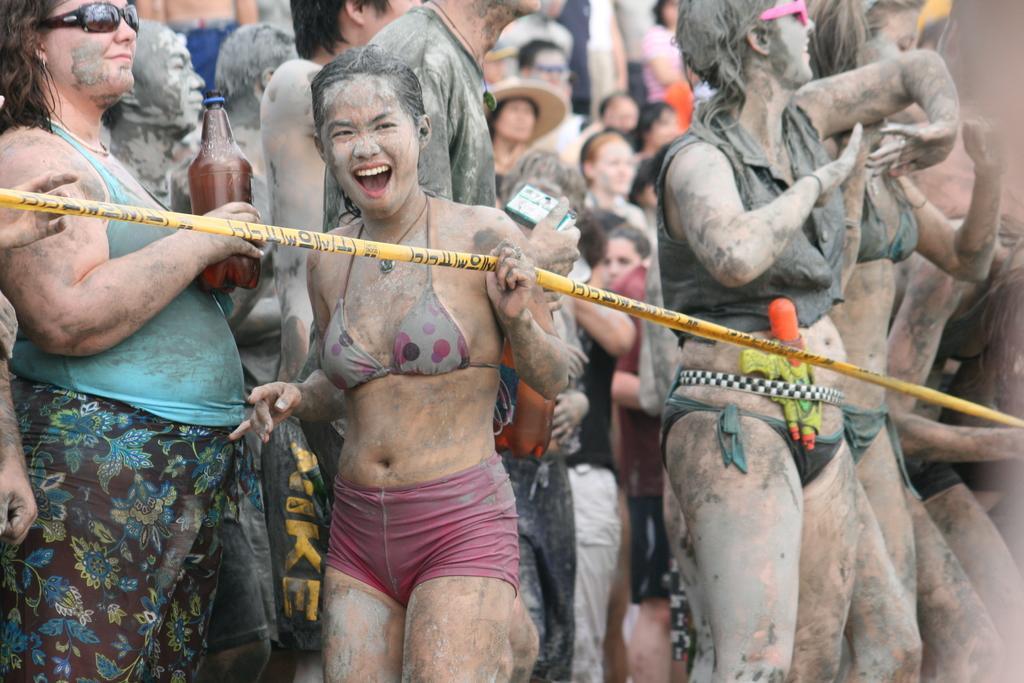Describe this image in one or two sentences. In this image, we can see persons wearing clothes. There is a person in the middle of the image holding a ribbon with her hand. There is an another person on the left side of the image holding a bottle with her hand. 